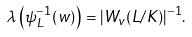Convert formula to latex. <formula><loc_0><loc_0><loc_500><loc_500>\lambda \left ( \psi _ { L } ^ { - 1 } ( w ) \right ) = | W _ { v } ( L / K ) | ^ { - 1 } .</formula> 